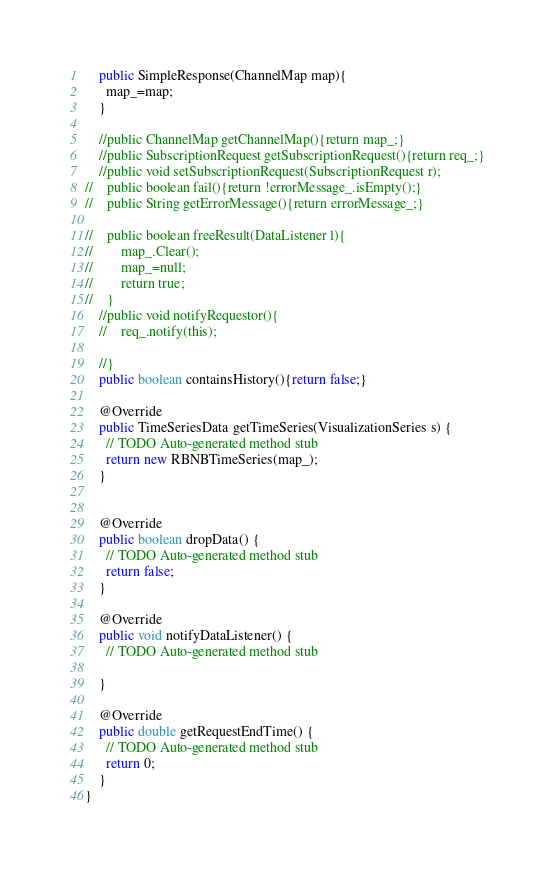Convert code to text. <code><loc_0><loc_0><loc_500><loc_500><_Java_>    public SimpleResponse(ChannelMap map){
      map_=map;
    }

    //public ChannelMap getChannelMap(){return map_;}
    //public SubscriptionRequest getSubscriptionRequest(){return req_;}
    //public void setSubscriptionRequest(SubscriptionRequest r);
//    public boolean fail(){return !errorMessage_.isEmpty();}
//    public String getErrorMessage(){return errorMessage_;}

//    public boolean freeResult(DataListener l){
//        map_.Clear();
//        map_=null;
//        return true;
//    }
    //public void notifyRequestor(){
    //    req_.notify(this);

    //}
    public boolean containsHistory(){return false;}

    @Override
    public TimeSeriesData getTimeSeries(VisualizationSeries s) {
      // TODO Auto-generated method stub
      return new RBNBTimeSeries(map_);
    }

    
    @Override
    public boolean dropData() {
      // TODO Auto-generated method stub
      return false;
    }

    @Override
    public void notifyDataListener() {
      // TODO Auto-generated method stub
      
    }

    @Override
    public double getRequestEndTime() {
      // TODO Auto-generated method stub
      return 0;
    }
}
</code> 